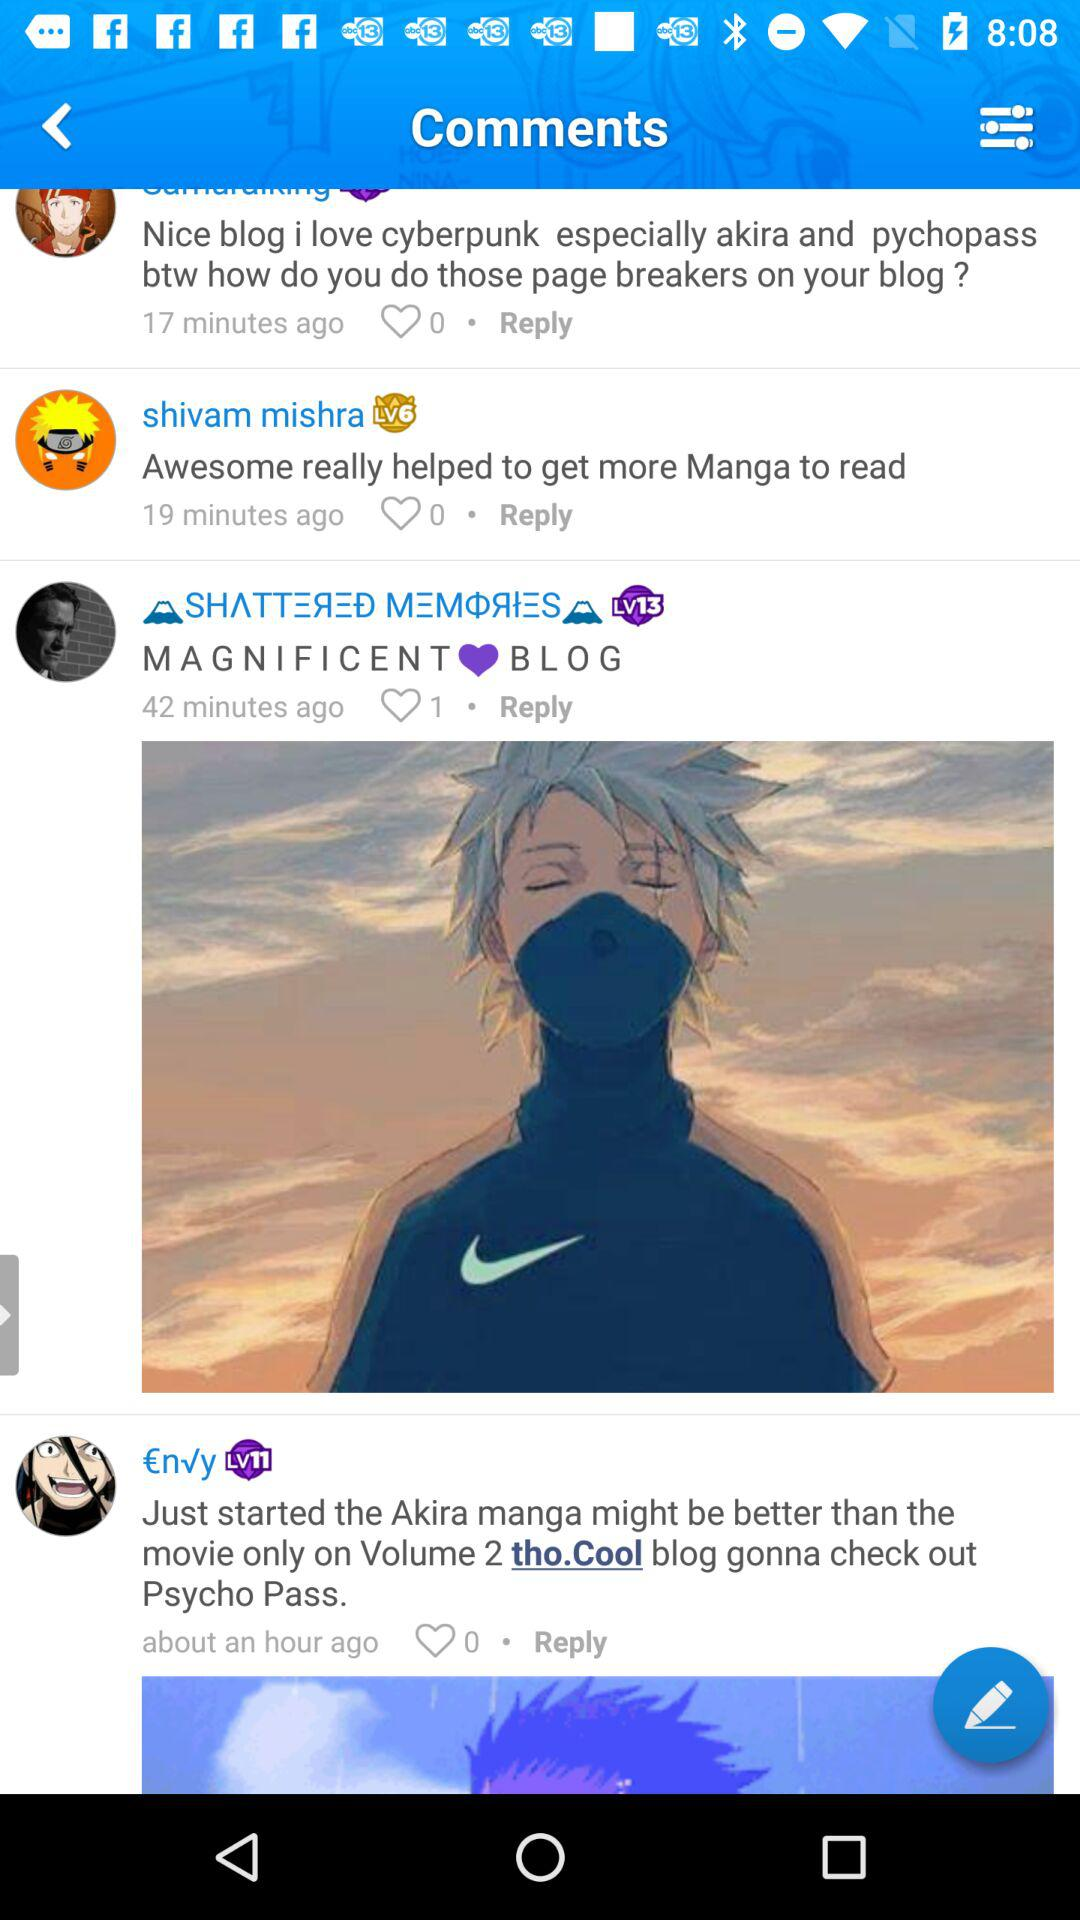When was the comment "MAGNIFICENT BLOG" posted? The comment "MAGNIFICENT BLOG" was posted 42 minutes ago. 